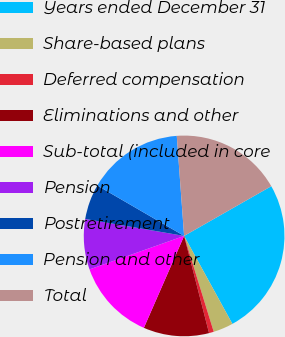Convert chart to OTSL. <chart><loc_0><loc_0><loc_500><loc_500><pie_chart><fcel>Years ended December 31<fcel>Share-based plans<fcel>Deferred compensation<fcel>Eliminations and other<fcel>Sub-total (included in core<fcel>Pension<fcel>Postretirement<fcel>Pension and other<fcel>Total<nl><fcel>25.27%<fcel>3.22%<fcel>0.77%<fcel>10.57%<fcel>13.02%<fcel>8.12%<fcel>5.67%<fcel>15.47%<fcel>17.92%<nl></chart> 